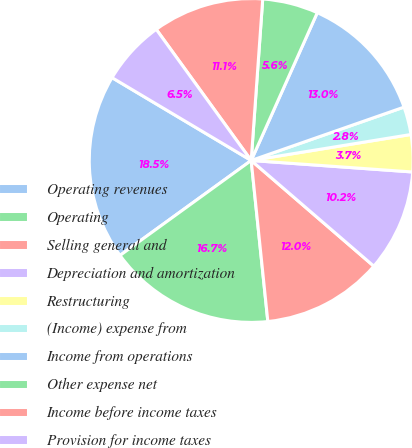<chart> <loc_0><loc_0><loc_500><loc_500><pie_chart><fcel>Operating revenues<fcel>Operating<fcel>Selling general and<fcel>Depreciation and amortization<fcel>Restructuring<fcel>(Income) expense from<fcel>Income from operations<fcel>Other expense net<fcel>Income before income taxes<fcel>Provision for income taxes<nl><fcel>18.52%<fcel>16.67%<fcel>12.04%<fcel>10.19%<fcel>3.7%<fcel>2.78%<fcel>12.96%<fcel>5.56%<fcel>11.11%<fcel>6.48%<nl></chart> 